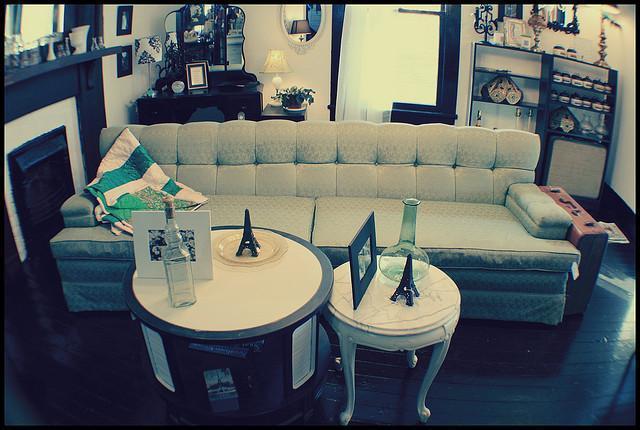How many red bottles are in the picture?
Give a very brief answer. 0. 